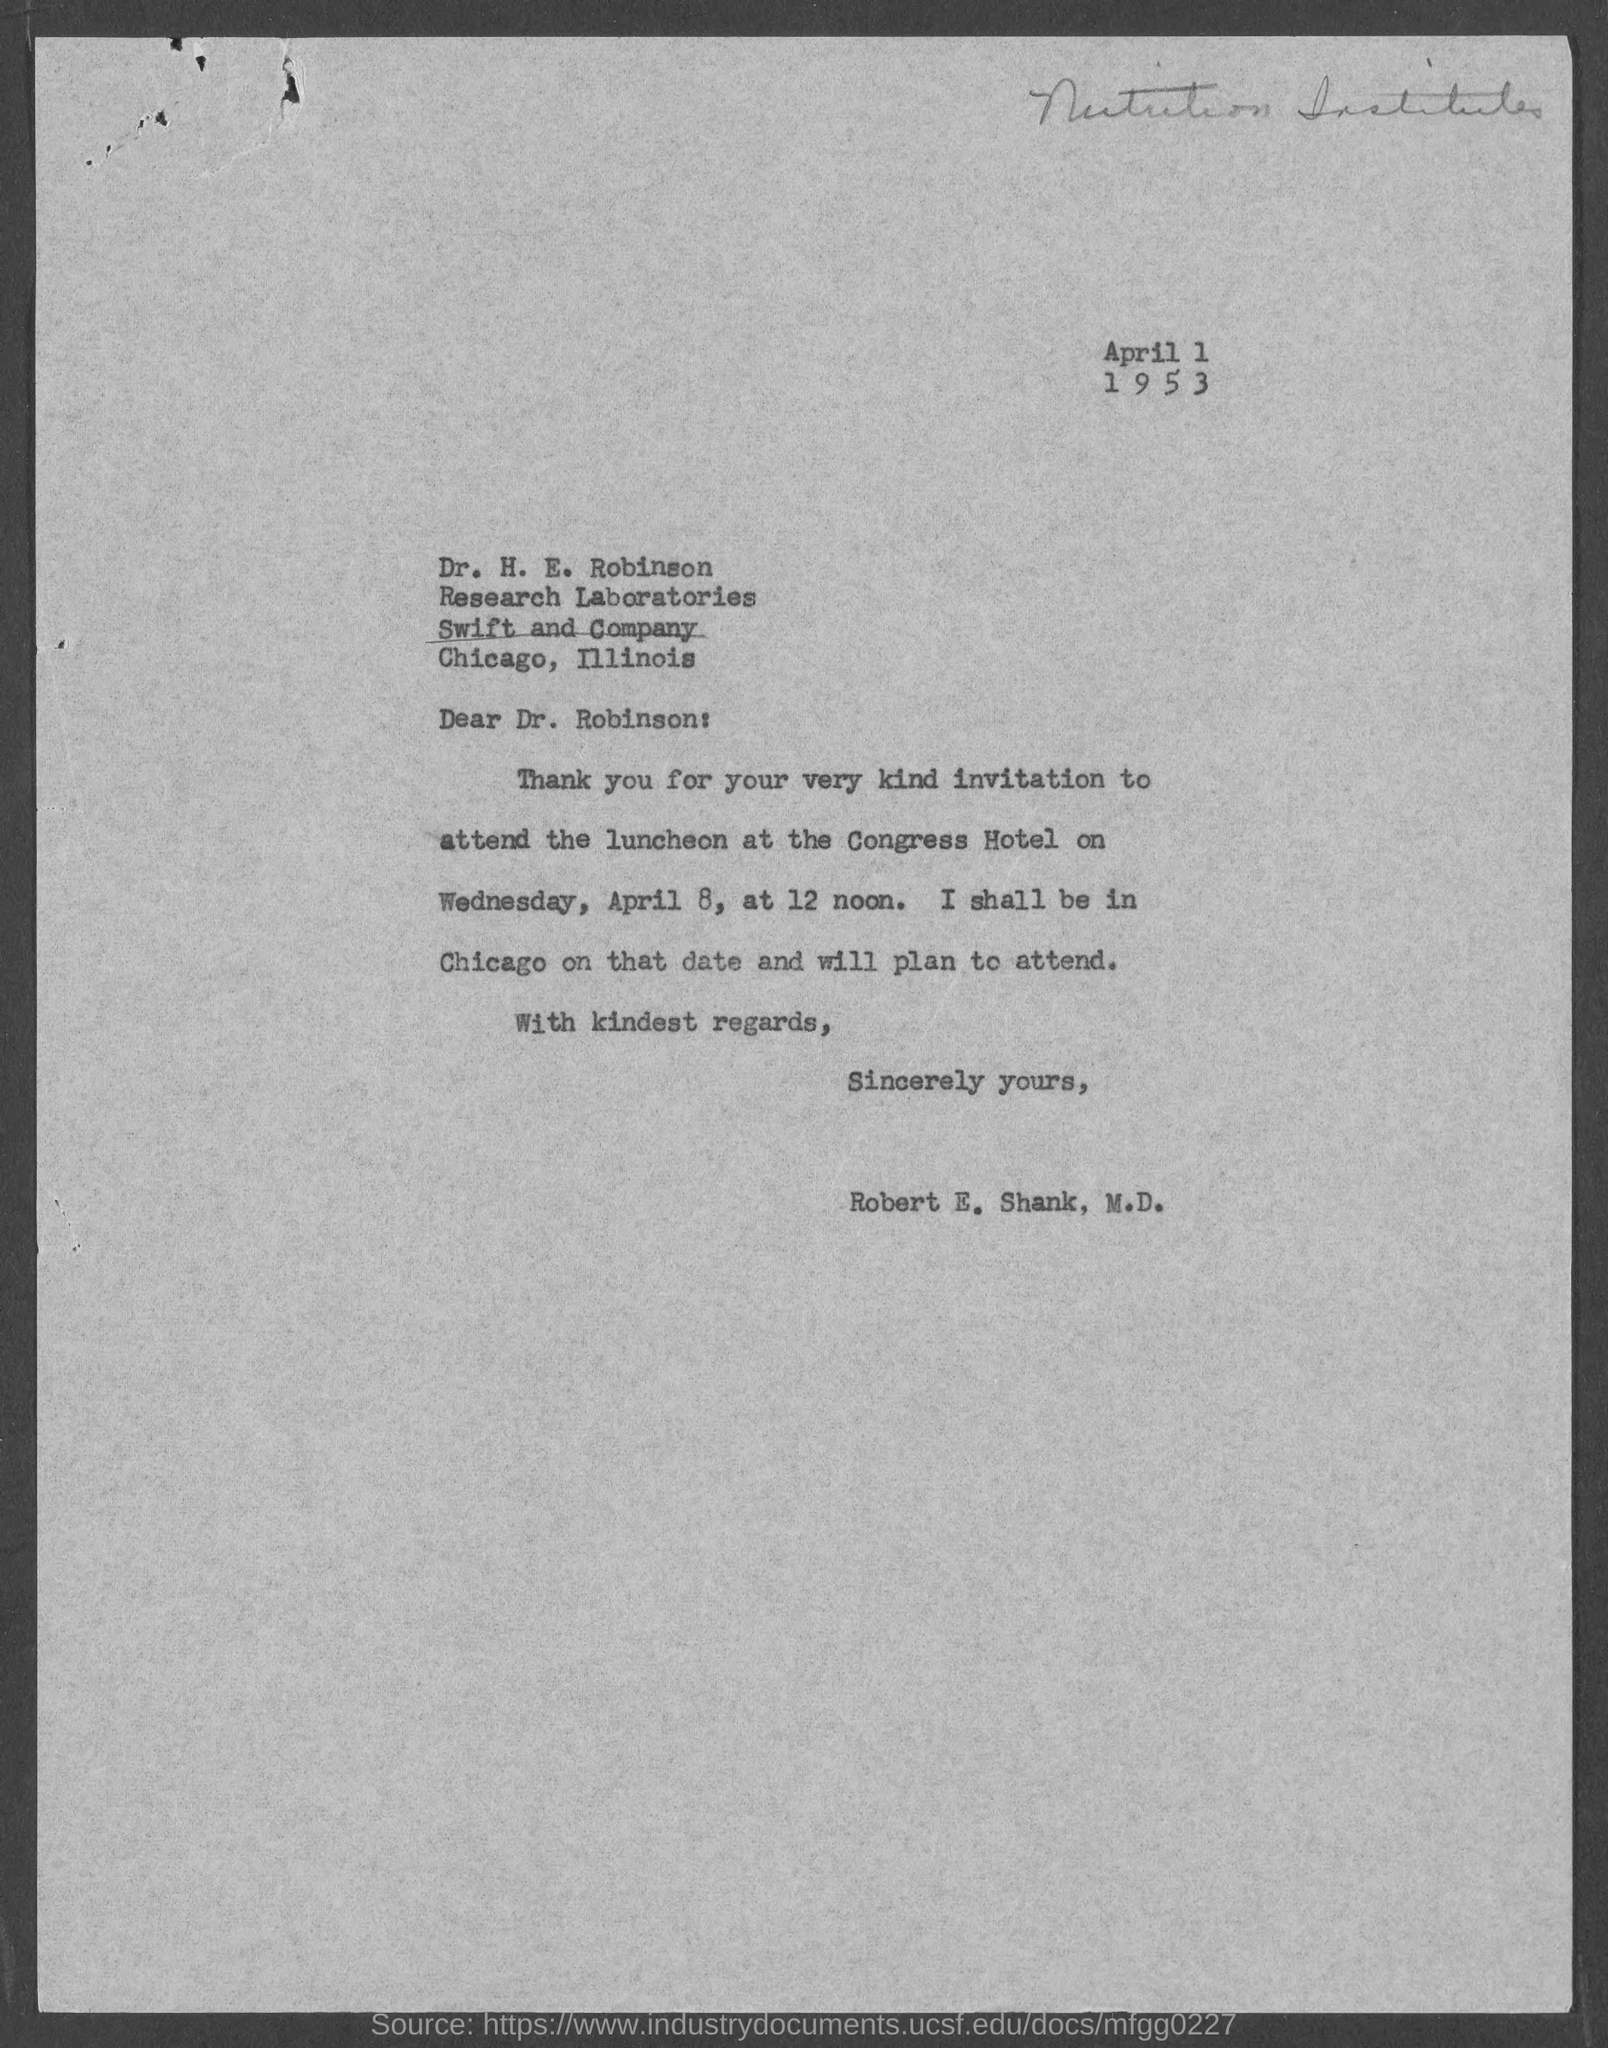Point out several critical features in this image. The memorandum is from Robert E. Shank, M.D. The memorandum is addressed to Dr. Robinson. 